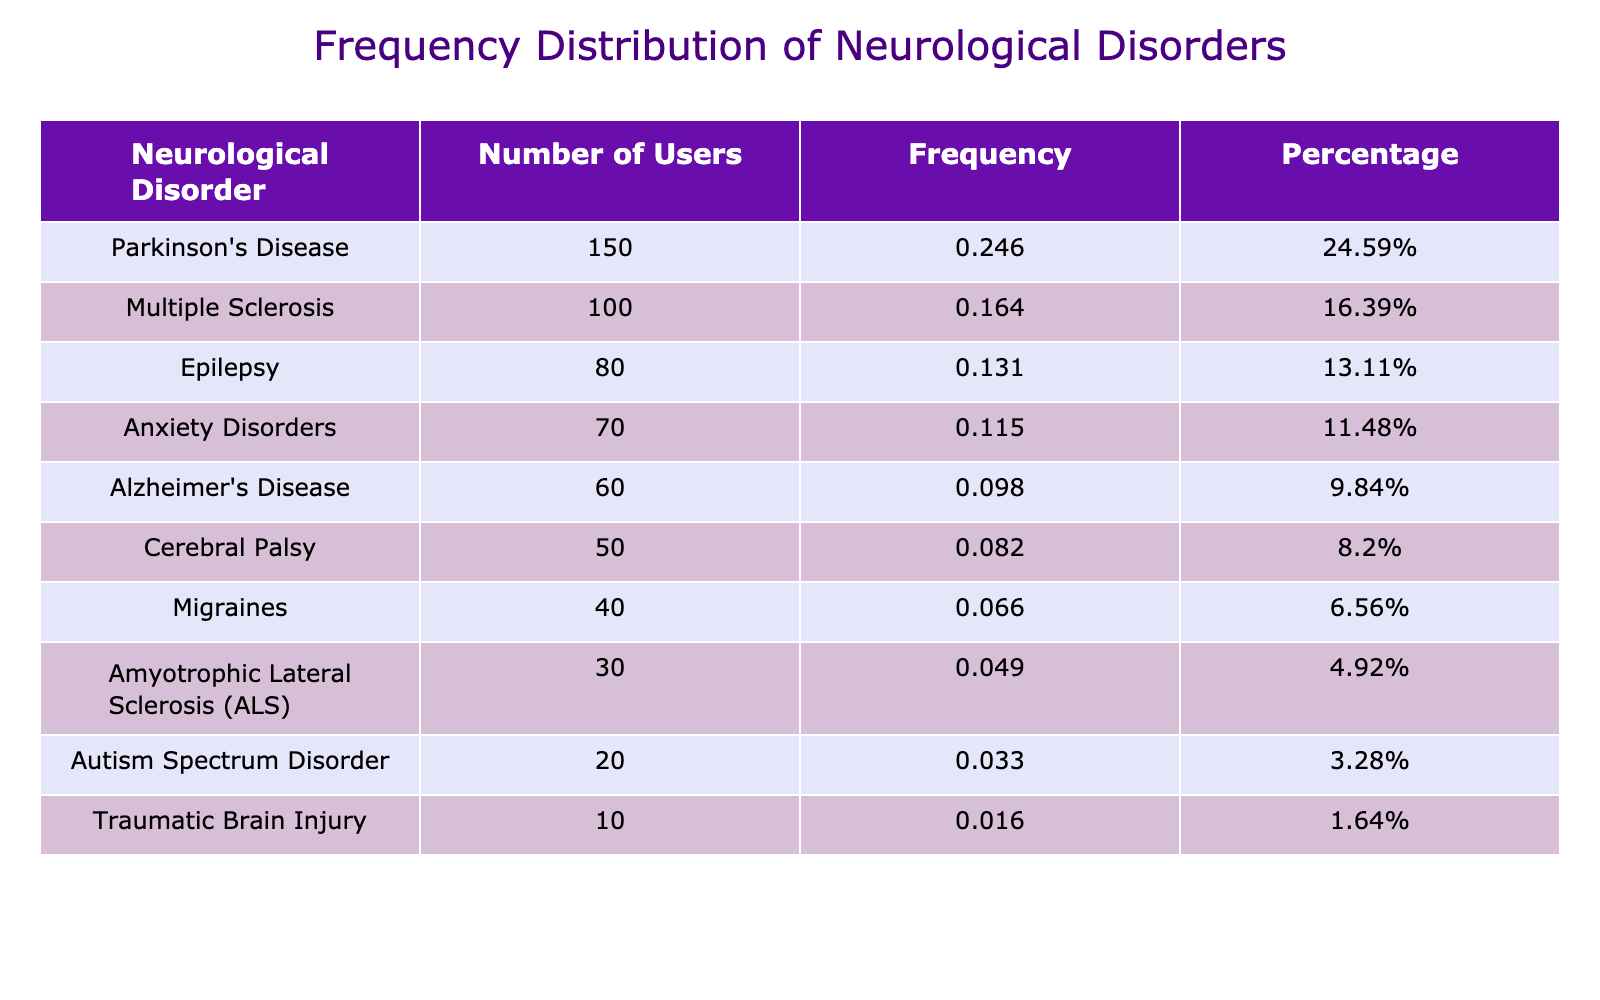What is the most common neurological disorder among users of the inventor's devices? The highest number of users is associated with Parkinson's Disease, which has 150 users listed in the table.
Answer: Parkinson's Disease How many users are suffering from Multiple Sclerosis? The table explicitly lists Multiple Sclerosis with a value of 100 users.
Answer: 100 What percentage of users have Epilepsy? To find the percentage, we see that there are 80 users with Epilepsy. The total number of users is 150+100+80+60+30+50+40+70+20+10 = 620. The percentage is calculated as (80/620) * 100 = 12.90%.
Answer: 12.90% Is the number of users with Traumatic Brain Injury higher than those with Autism Spectrum Disorder? The table shows 10 users for Traumatic Brain Injury and 20 for Autism Spectrum Disorder; thus, 10 is not higher than 20.
Answer: No What is the total number of users with Anxiety Disorders and Migraines combined? To find this, add the respective user counts: Anxiety Disorders has 70 users and Migraines has 40 users. Therefore, 70 + 40 = 110 users combined.
Answer: 110 What is the average number of users for all disorders listed in the table? First, we need to find the total number of users, which is 620. There are 10 different neurological disorders in the table, so the average is 620 / 10 = 62.
Answer: 62 Which disorder has the least number of users, and how many users does it have? The table lists Traumatic Brain Injury with the lowest number of users, which is 10.
Answer: Traumatic Brain Injury, 10 What is the total count of users for all disorders except for Alzheimer's Disease and Autism Spectrum Disorder? First, we add the users from all disorders: 620 total. Then, subtract the users: Alzheimer's Disease (60) and Autism Spectrum Disorder (20). So, 620 - 60 - 20 = 540 users.
Answer: 540 